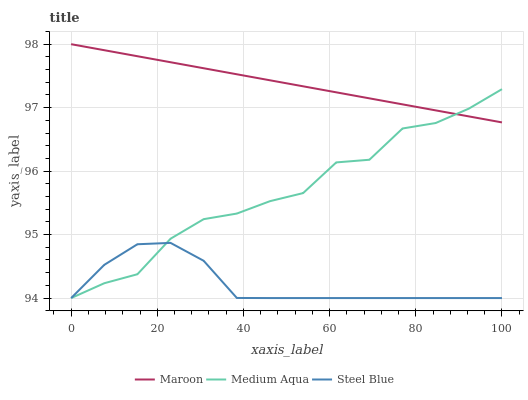Does Maroon have the minimum area under the curve?
Answer yes or no. No. Does Steel Blue have the maximum area under the curve?
Answer yes or no. No. Is Steel Blue the smoothest?
Answer yes or no. No. Is Steel Blue the roughest?
Answer yes or no. No. Does Maroon have the lowest value?
Answer yes or no. No. Does Steel Blue have the highest value?
Answer yes or no. No. Is Steel Blue less than Maroon?
Answer yes or no. Yes. Is Maroon greater than Steel Blue?
Answer yes or no. Yes. Does Steel Blue intersect Maroon?
Answer yes or no. No. 